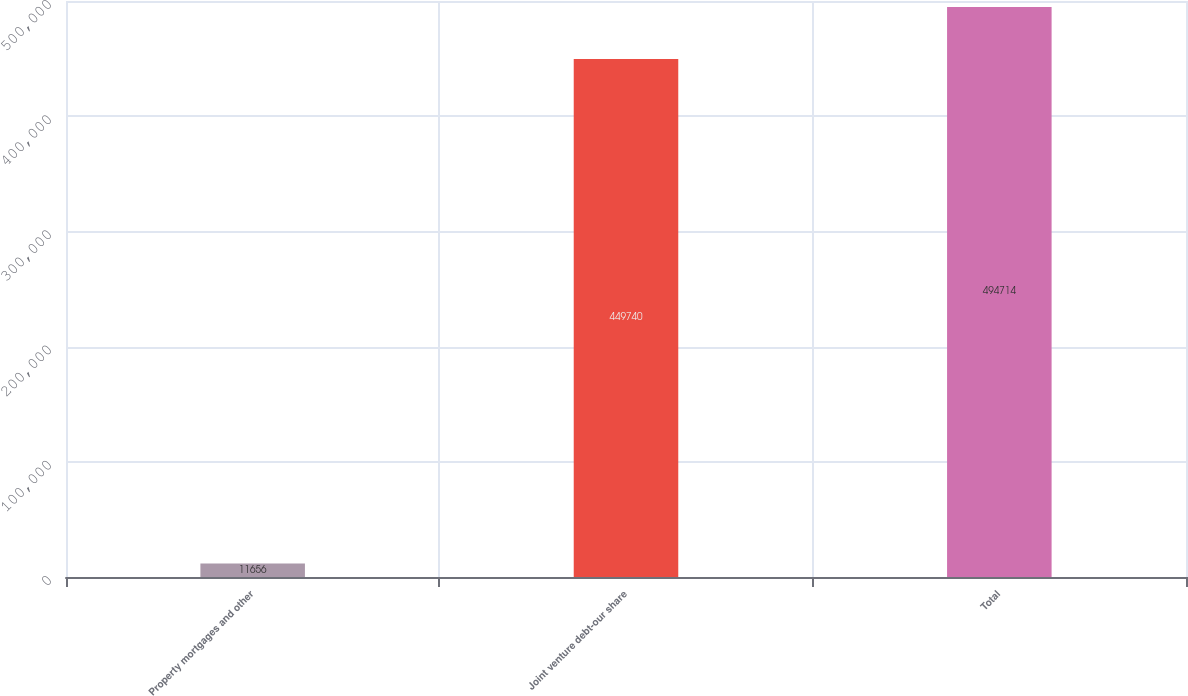Convert chart. <chart><loc_0><loc_0><loc_500><loc_500><bar_chart><fcel>Property mortgages and other<fcel>Joint venture debt-our share<fcel>Total<nl><fcel>11656<fcel>449740<fcel>494714<nl></chart> 